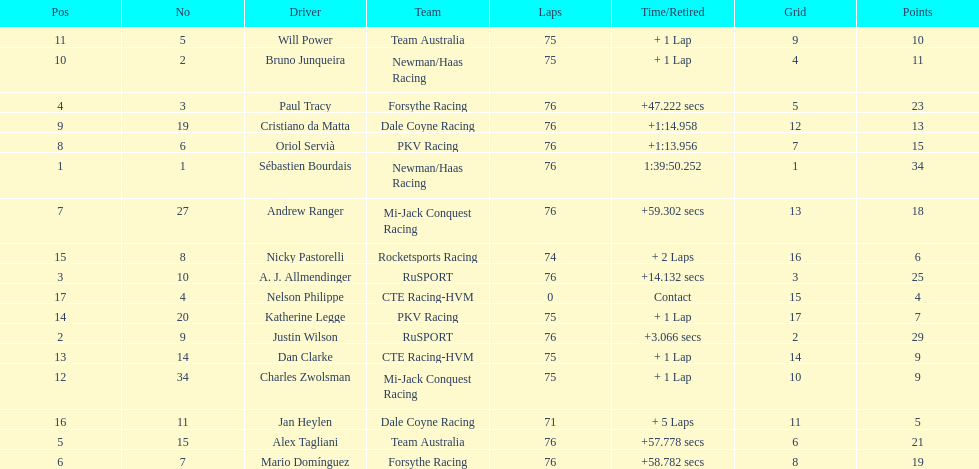Parse the table in full. {'header': ['Pos', 'No', 'Driver', 'Team', 'Laps', 'Time/Retired', 'Grid', 'Points'], 'rows': [['11', '5', 'Will Power', 'Team Australia', '75', '+ 1 Lap', '9', '10'], ['10', '2', 'Bruno Junqueira', 'Newman/Haas Racing', '75', '+ 1 Lap', '4', '11'], ['4', '3', 'Paul Tracy', 'Forsythe Racing', '76', '+47.222 secs', '5', '23'], ['9', '19', 'Cristiano da Matta', 'Dale Coyne Racing', '76', '+1:14.958', '12', '13'], ['8', '6', 'Oriol Servià', 'PKV Racing', '76', '+1:13.956', '7', '15'], ['1', '1', 'Sébastien Bourdais', 'Newman/Haas Racing', '76', '1:39:50.252', '1', '34'], ['7', '27', 'Andrew Ranger', 'Mi-Jack Conquest Racing', '76', '+59.302 secs', '13', '18'], ['15', '8', 'Nicky Pastorelli', 'Rocketsports Racing', '74', '+ 2 Laps', '16', '6'], ['3', '10', 'A. J. Allmendinger', 'RuSPORT', '76', '+14.132 secs', '3', '25'], ['17', '4', 'Nelson Philippe', 'CTE Racing-HVM', '0', 'Contact', '15', '4'], ['14', '20', 'Katherine Legge', 'PKV Racing', '75', '+ 1 Lap', '17', '7'], ['2', '9', 'Justin Wilson', 'RuSPORT', '76', '+3.066 secs', '2', '29'], ['13', '14', 'Dan Clarke', 'CTE Racing-HVM', '75', '+ 1 Lap', '14', '9'], ['12', '34', 'Charles Zwolsman', 'Mi-Jack Conquest Racing', '75', '+ 1 Lap', '10', '9'], ['16', '11', 'Jan Heylen', 'Dale Coyne Racing', '71', '+ 5 Laps', '11', '5'], ['5', '15', 'Alex Tagliani', 'Team Australia', '76', '+57.778 secs', '6', '21'], ['6', '7', 'Mario Domínguez', 'Forsythe Racing', '76', '+58.782 secs', '8', '19']]} How many positions are held by canada? 3. 